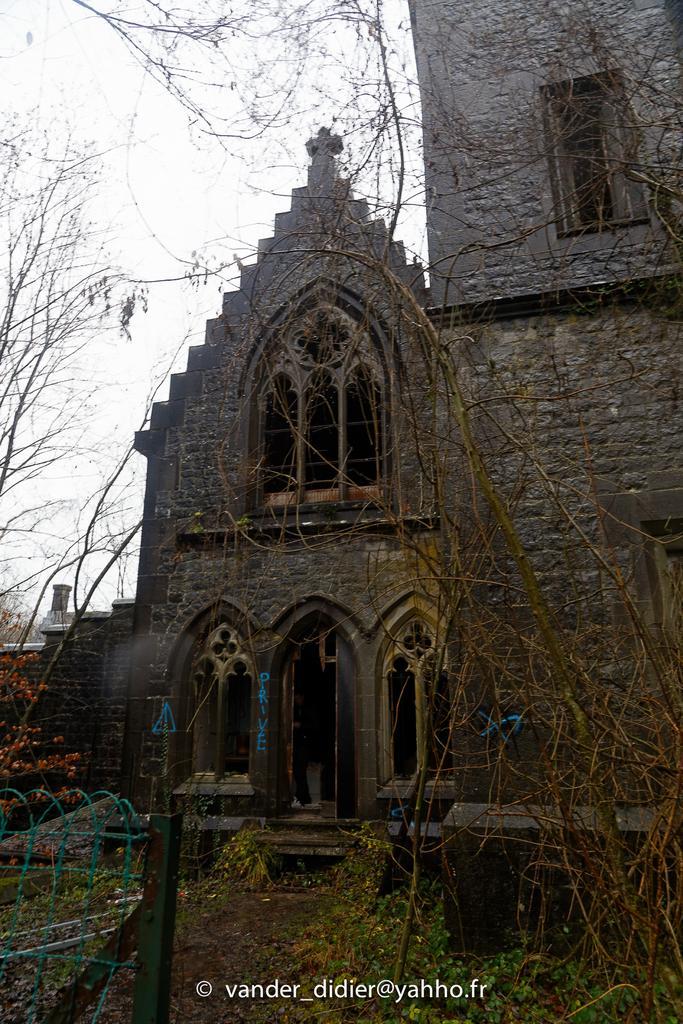In one or two sentences, can you explain what this image depicts? In the middle it looks like a church, there are trees in this image, at the top it is the sky. 